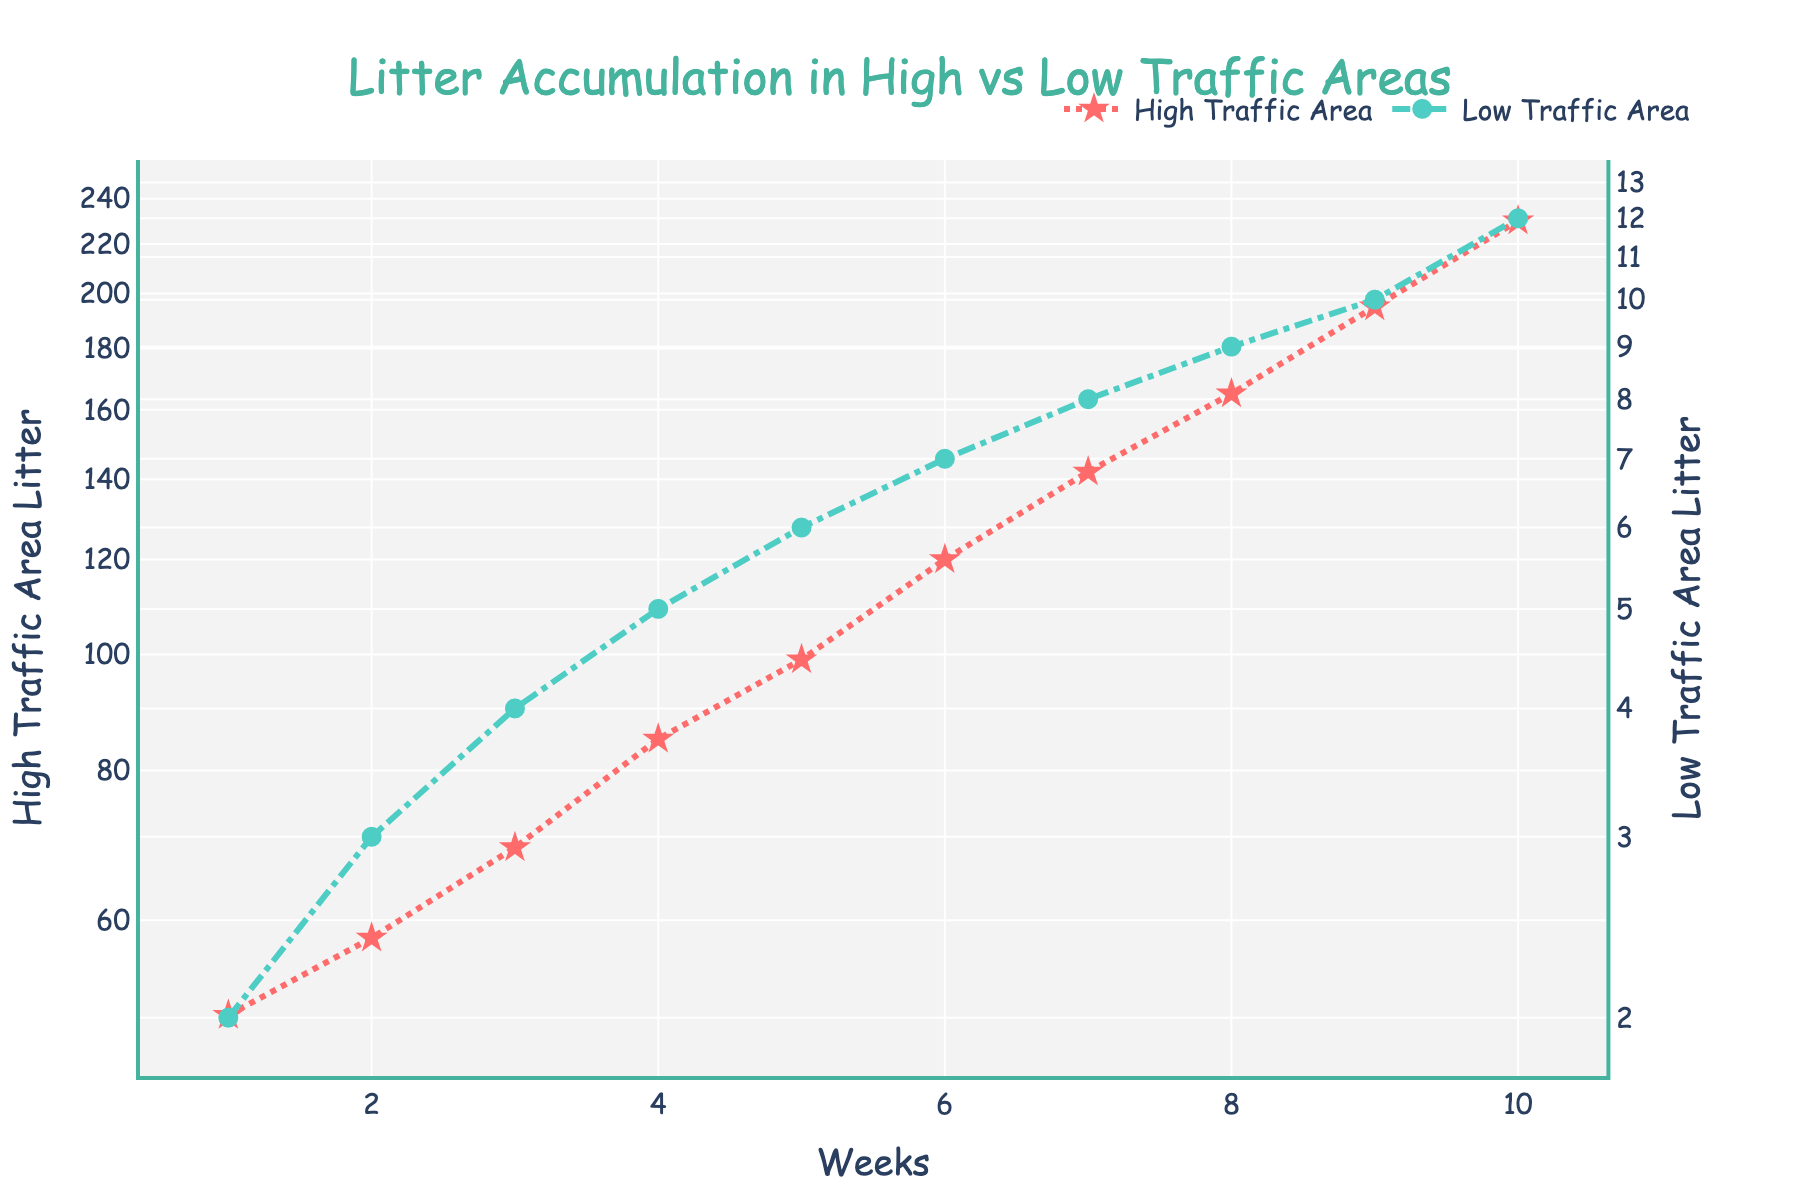What is the title of the plot? The title of the plot is usually positioned at the top of the figure, and in this case, it reads "Litter Accumulation in High vs Low Traffic Areas."
Answer: Litter Accumulation in High vs Low Traffic Areas How many data points are shown for each area? Each area has one data point per week. Since there are 10 weeks, each area has 10 data points.
Answer: 10 What does the x-axis represent? The x-axis represents the weeks, indicating the time intervals over which the litter accumulation is measured.
Answer: Weeks What are the colors used to represent High Traffic Area and Low Traffic Area litter on the plot? The High Traffic Area is represented by star markers and a dot-dashed red line, and the Low Traffic Area is represented by circle markers and a dash-dot teal line.
Answer: Red and Teal How does the litter accumulation in High Traffic Areas compare to Low Traffic Areas at Week 5? By visually comparing the values at Week 5 for both areas, High Traffic Area litter is approximately 99 while Low Traffic Area litter is around 6. High Traffic Area has significantly more litter.
Answer: High Traffic Area has significantly more litter What is the average litter accumulation over the 10 weeks for High Traffic Areas? Sum the litter values for High Traffic Areas over 10 weeks and divide by 10: (50 + 58 + 69 + 85 + 99 + 120 + 142 + 165 + 195 + 230)/10 = 1213/10. Therefore, the average is 121.3.
Answer: 121.3 Between Weeks 3 and 4, which area sees a greater increase in litter accumulation? Calculate the increase for each area: for High Traffic Areas, it's 85 - 69 = 16, for Low Traffic Areas, it's 5 - 4 = 1. Thus, High Traffic Areas see a greater increase.
Answer: High Traffic Area By how much does the litter increase in Low Traffic Areas from Week 1 to Week 10? Subtract the Week 1 value from the Week 10 value for Low Traffic Areas: 12 - 2 = 10. So, the increase is 10 units.
Answer: 10 units What's the litter accumulation rate difference between High and Low Traffic Areas at Week 7? The litter value at Week 7 for High Traffic Areas is 142, and for Low Traffic Areas, it is 8. The difference is 142 - 8 = 134.
Answer: 134 What does using a log scale on the y-axes indicate about the litter data? Using a log scale on the y-axes indicates that the litter data spans several orders of magnitude, allowing for better visualization of differences in litter accumulation that might be less apparent on a linear scale.
Answer: Data spans several orders of magnitude 